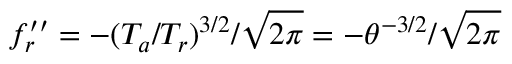Convert formula to latex. <formula><loc_0><loc_0><loc_500><loc_500>f _ { r } ^ { \prime \prime } = - ( T _ { a } / T _ { r } ) ^ { 3 / 2 } / \sqrt { 2 \pi } = - \theta ^ { - 3 / 2 } / \sqrt { 2 \pi }</formula> 